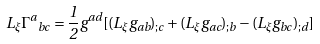<formula> <loc_0><loc_0><loc_500><loc_500>L _ { \xi } { \Gamma ^ { a } } _ { b c } = \frac { 1 } { 2 } g ^ { a d } [ ( L _ { \xi } g _ { a b } ) _ { ; c } + ( L _ { \xi } g _ { a c } ) _ { ; b } - ( L _ { \xi } g _ { b c } ) _ { ; d } ]</formula> 